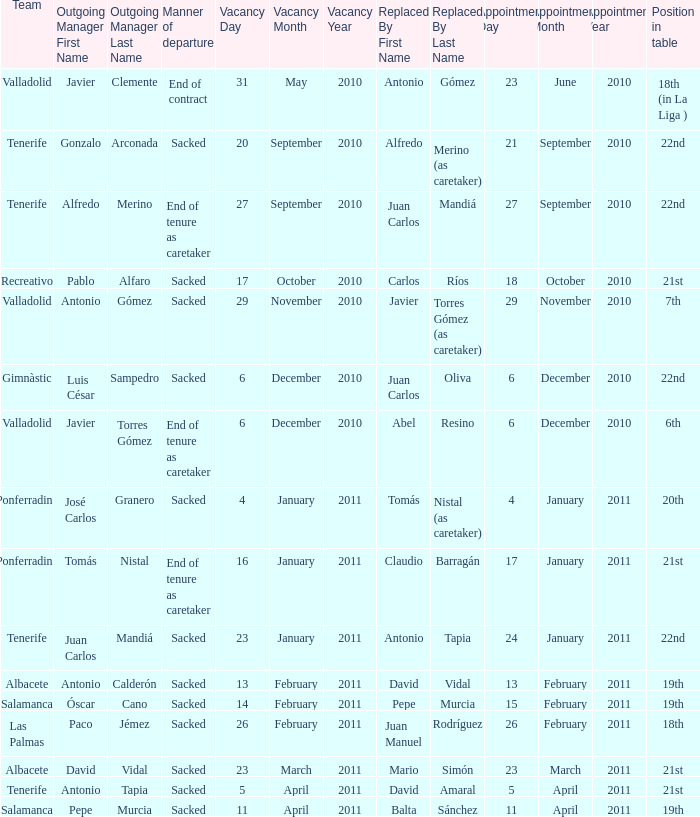What was the appointment date for outgoing manager luis césar sampedro 6 December 2010. 